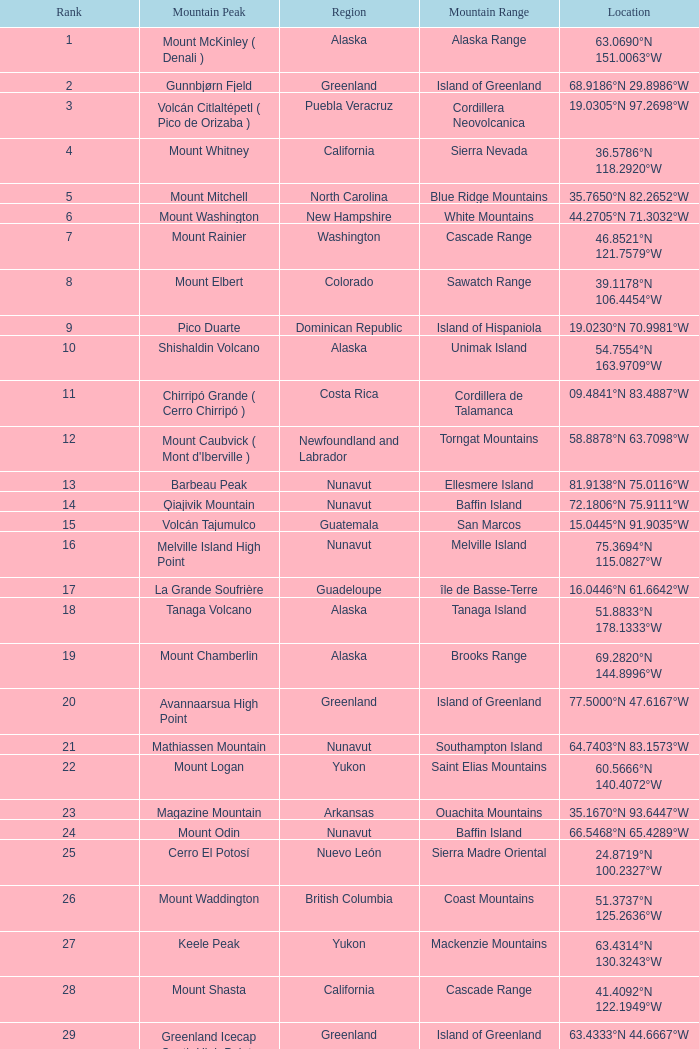Identify the area containing a mountain summit called dillingham high point? Alaska. 